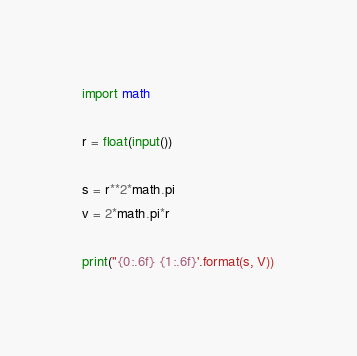<code> <loc_0><loc_0><loc_500><loc_500><_Python_>import math

r = float(input())

s = r**2*math.pi
v = 2*math.pi*r

print("{0:.6f} {1:.6f}'.format(s, V))</code> 